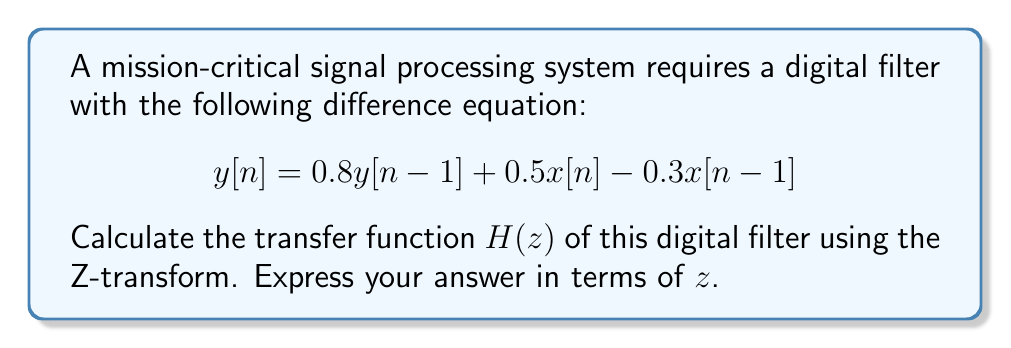Give your solution to this math problem. To find the transfer function $H(z)$ of the digital filter, we need to apply the Z-transform to both sides of the difference equation and then solve for $Y(z)/X(z)$. Let's proceed step-by-step:

1. Apply the Z-transform to both sides of the equation:
   $$Z\{y[n]\} = Z\{0.8y[n-1] + 0.5x[n] - 0.3x[n-1]\}$$

2. Use the linearity property and the time-shift property of the Z-transform:
   $$Y(z) = 0.8z^{-1}Y(z) + 0.5X(z) - 0.3z^{-1}X(z)$$

3. Group terms with $Y(z)$ on the left side and terms with $X(z)$ on the right side:
   $$Y(z) - 0.8z^{-1}Y(z) = 0.5X(z) - 0.3z^{-1}X(z)$$

4. Factor out $Y(z)$ and $X(z)$:
   $$Y(z)(1 - 0.8z^{-1}) = X(z)(0.5 - 0.3z^{-1})$$

5. The transfer function $H(z)$ is defined as $Y(z)/X(z)$, so divide both sides by $X(z)$:
   $$H(z) = \frac{Y(z)}{X(z)} = \frac{0.5 - 0.3z^{-1}}{1 - 0.8z^{-1}}$$

6. Multiply numerator and denominator by $z$ to express $H(z)$ in positive powers of $z$:
   $$H(z) = \frac{(0.5 - 0.3z^{-1})z}{(1 - 0.8z^{-1})z} = \frac{0.5z - 0.3}{z - 0.8}$$

This is the final form of the transfer function $H(z)$ for the given digital filter.
Answer: $$H(z) = \frac{0.5z - 0.3}{z - 0.8}$$ 